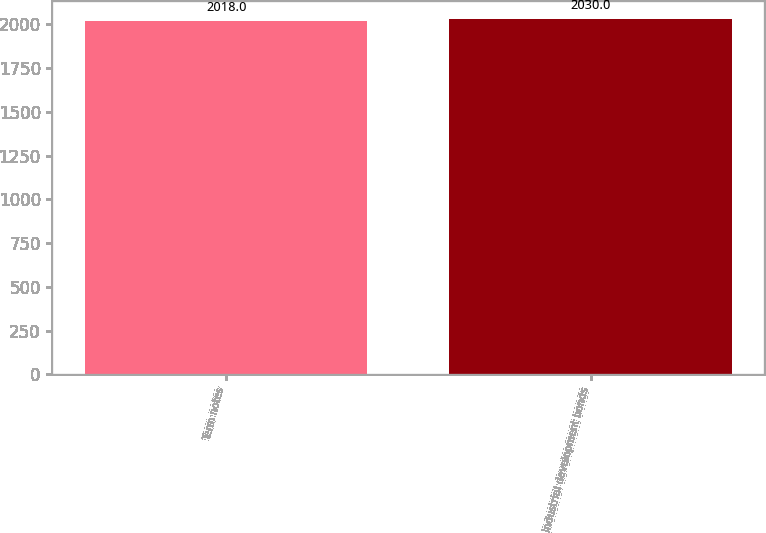Convert chart. <chart><loc_0><loc_0><loc_500><loc_500><bar_chart><fcel>Term notes<fcel>Industrial development bonds<nl><fcel>2018<fcel>2030<nl></chart> 